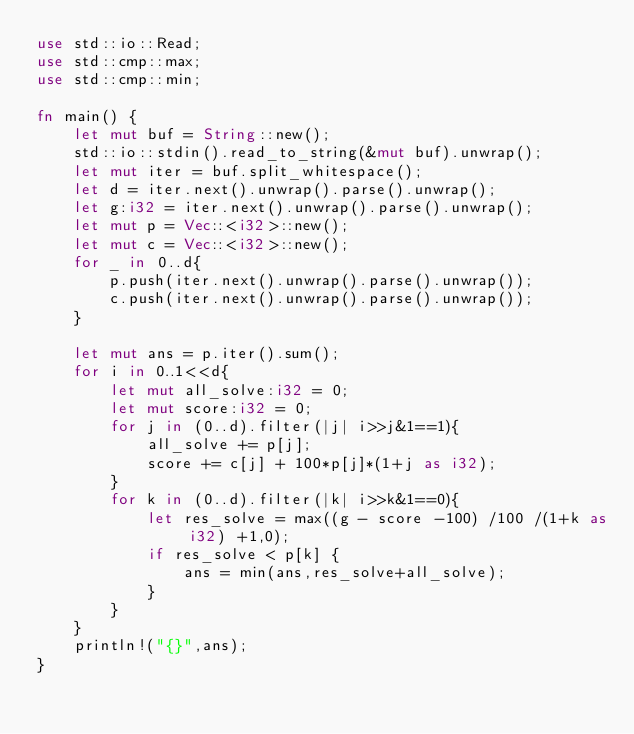<code> <loc_0><loc_0><loc_500><loc_500><_Rust_>use std::io::Read;
use std::cmp::max;
use std::cmp::min;

fn main() {
    let mut buf = String::new();
    std::io::stdin().read_to_string(&mut buf).unwrap();
    let mut iter = buf.split_whitespace();
    let d = iter.next().unwrap().parse().unwrap();
    let g:i32 = iter.next().unwrap().parse().unwrap();
    let mut p = Vec::<i32>::new();
    let mut c = Vec::<i32>::new();
    for _ in 0..d{
        p.push(iter.next().unwrap().parse().unwrap());
        c.push(iter.next().unwrap().parse().unwrap());
    }

    let mut ans = p.iter().sum();
    for i in 0..1<<d{
        let mut all_solve:i32 = 0;
        let mut score:i32 = 0;
        for j in (0..d).filter(|j| i>>j&1==1){
            all_solve += p[j];
            score += c[j] + 100*p[j]*(1+j as i32);
        }
        for k in (0..d).filter(|k| i>>k&1==0){
            let res_solve = max((g - score -100) /100 /(1+k as i32) +1,0);
            if res_solve < p[k] {
                ans = min(ans,res_solve+all_solve);
            }
        }
    }
    println!("{}",ans);
}
</code> 